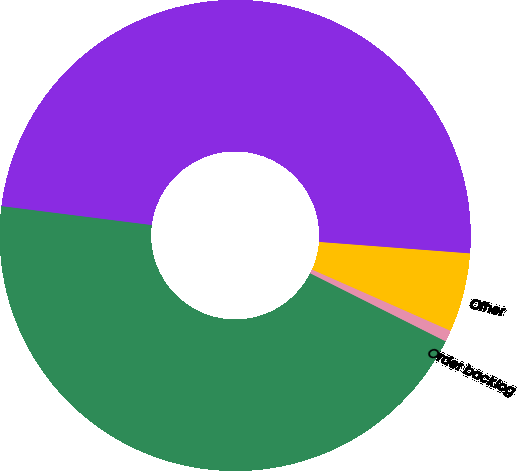<chart> <loc_0><loc_0><loc_500><loc_500><pie_chart><fcel>Technology<fcel>Order backlog<fcel>Other<fcel>Total<nl><fcel>44.58%<fcel>0.79%<fcel>5.42%<fcel>49.21%<nl></chart> 